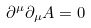Convert formula to latex. <formula><loc_0><loc_0><loc_500><loc_500>\partial ^ { \mu } \partial _ { \mu } A = 0</formula> 